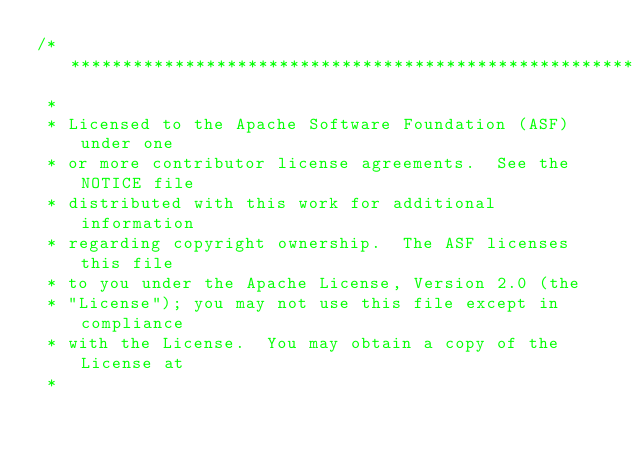Convert code to text. <code><loc_0><loc_0><loc_500><loc_500><_C++_>/**************************************************************
 * 
 * Licensed to the Apache Software Foundation (ASF) under one
 * or more contributor license agreements.  See the NOTICE file
 * distributed with this work for additional information
 * regarding copyright ownership.  The ASF licenses this file
 * to you under the Apache License, Version 2.0 (the
 * "License"); you may not use this file except in compliance
 * with the License.  You may obtain a copy of the License at
 * </code> 